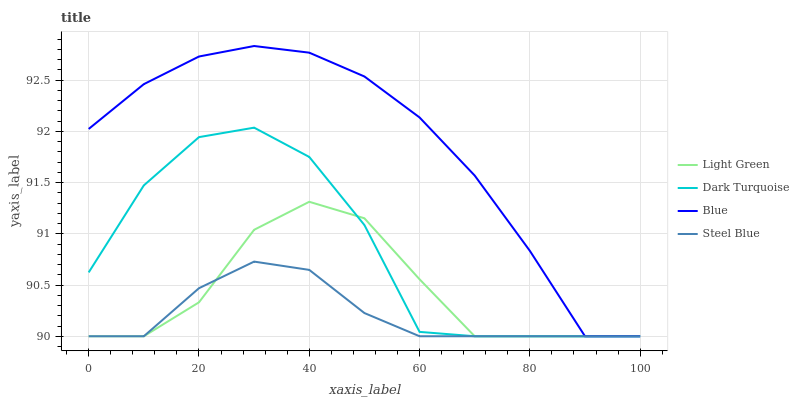Does Steel Blue have the minimum area under the curve?
Answer yes or no. Yes. Does Blue have the maximum area under the curve?
Answer yes or no. Yes. Does Dark Turquoise have the minimum area under the curve?
Answer yes or no. No. Does Dark Turquoise have the maximum area under the curve?
Answer yes or no. No. Is Steel Blue the smoothest?
Answer yes or no. Yes. Is Dark Turquoise the roughest?
Answer yes or no. Yes. Is Dark Turquoise the smoothest?
Answer yes or no. No. Is Steel Blue the roughest?
Answer yes or no. No. Does Blue have the lowest value?
Answer yes or no. Yes. Does Blue have the highest value?
Answer yes or no. Yes. Does Dark Turquoise have the highest value?
Answer yes or no. No. Does Light Green intersect Blue?
Answer yes or no. Yes. Is Light Green less than Blue?
Answer yes or no. No. Is Light Green greater than Blue?
Answer yes or no. No. 